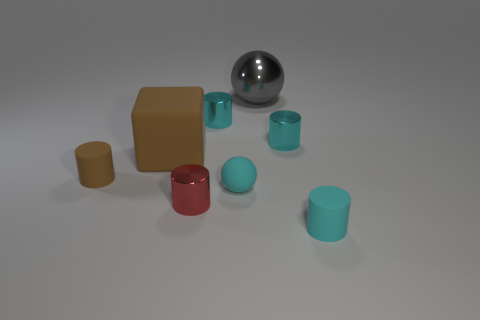Subtract all cyan cubes. How many cyan cylinders are left? 3 Subtract all red shiny cylinders. How many cylinders are left? 4 Add 1 tiny cyan metallic cylinders. How many objects exist? 9 Subtract all red cylinders. How many cylinders are left? 4 Add 3 tiny cyan balls. How many tiny cyan balls exist? 4 Subtract 0 purple cylinders. How many objects are left? 8 Subtract all spheres. How many objects are left? 6 Subtract all red spheres. Subtract all red cylinders. How many spheres are left? 2 Subtract all tiny brown rubber objects. Subtract all gray shiny things. How many objects are left? 6 Add 2 small red objects. How many small red objects are left? 3 